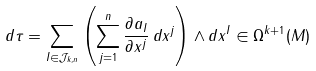<formula> <loc_0><loc_0><loc_500><loc_500>d \tau = \sum _ { I \in { \mathcal { J } } _ { k , n } } \left ( \sum _ { j = 1 } ^ { n } { \frac { \partial a _ { I } } { \partial x ^ { j } } } \, d x ^ { j } \right ) \wedge d x ^ { I } \in \Omega ^ { k + 1 } ( M )</formula> 